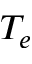<formula> <loc_0><loc_0><loc_500><loc_500>T _ { e }</formula> 